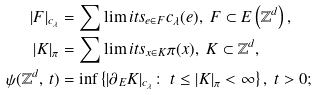Convert formula to latex. <formula><loc_0><loc_0><loc_500><loc_500>| F | _ { c _ { \lambda } } & = \sum \lim i t s _ { e \in F } c _ { \lambda } ( e ) , \ F \subset E \left ( \mathbb { Z } ^ { d } \right ) , \\ | K | _ { \pi } & = \sum \lim i t s _ { x \in K } \pi ( x ) , \ K \subset \mathbb { Z } ^ { d } , \\ \psi ( \mathbb { Z } ^ { d } , \, t ) & = \inf \left \{ | \partial _ { E } K | _ { c _ { \lambda } } \colon \ t \leq | K | _ { \pi } < \infty \right \} , \ t > 0 ;</formula> 